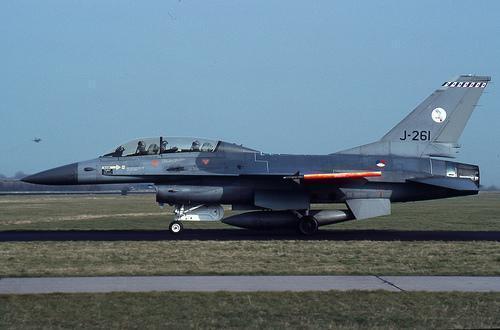How many people are seen inside the nearest plane?
Give a very brief answer. 2. 